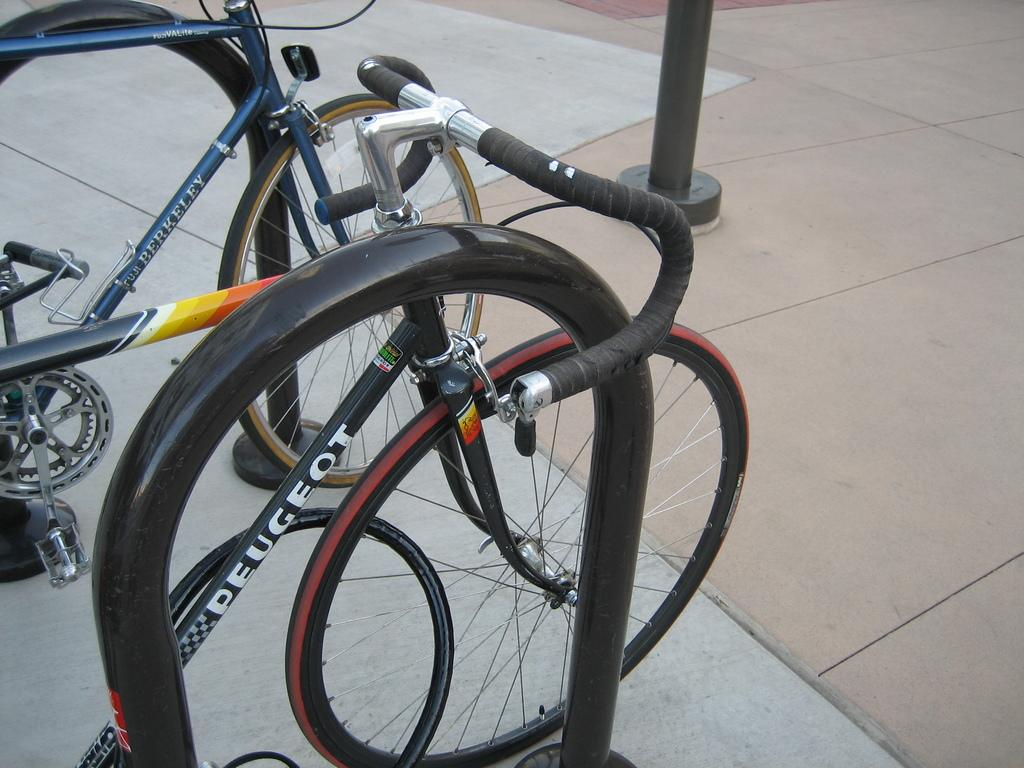What type of vehicles are in the image? There are bicycles in the image. What color is the rod next to the bicycles? The rod next to the bicycles is black. Can you describe the pole in the background of the image? There is a black color pole in the background of the image. What type of vest can be seen hanging on the moon in the image? There is no moon or vest present in the image. 